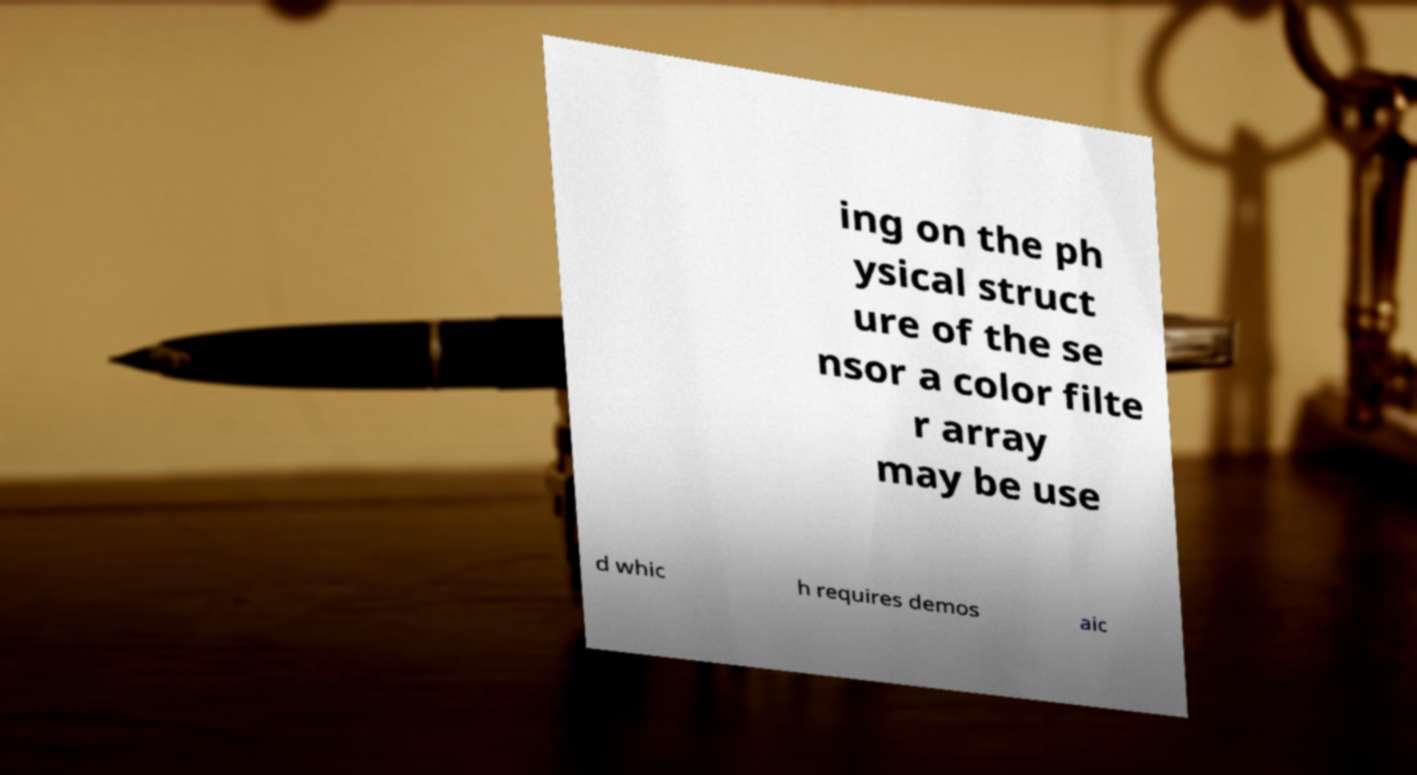Could you extract and type out the text from this image? ing on the ph ysical struct ure of the se nsor a color filte r array may be use d whic h requires demos aic 